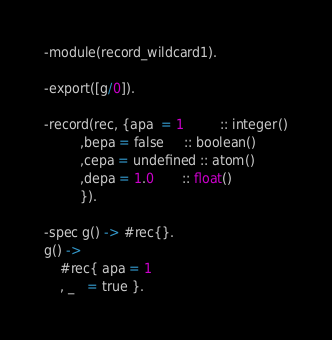Convert code to text. <code><loc_0><loc_0><loc_500><loc_500><_Erlang_>-module(record_wildcard1).

-export([g/0]).

-record(rec, {apa  = 1         :: integer()
	     ,bepa = false     :: boolean()
	     ,cepa = undefined :: atom()
	     ,depa = 1.0       :: float()
	     }).

-spec g() -> #rec{}.
g() ->
    #rec{ apa = 1
	, _   = true }.
</code> 